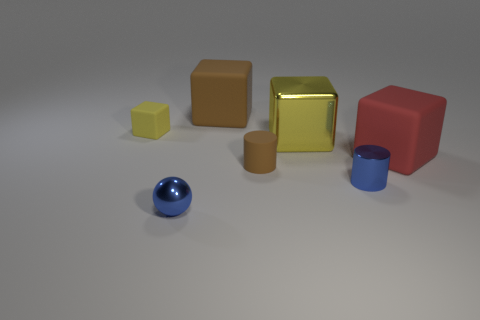Add 3 gray rubber cylinders. How many objects exist? 10 Subtract all balls. How many objects are left? 6 Add 3 tiny yellow matte balls. How many tiny yellow matte balls exist? 3 Subtract 0 purple spheres. How many objects are left? 7 Subtract all large red rubber cubes. Subtract all large cyan objects. How many objects are left? 6 Add 2 cylinders. How many cylinders are left? 4 